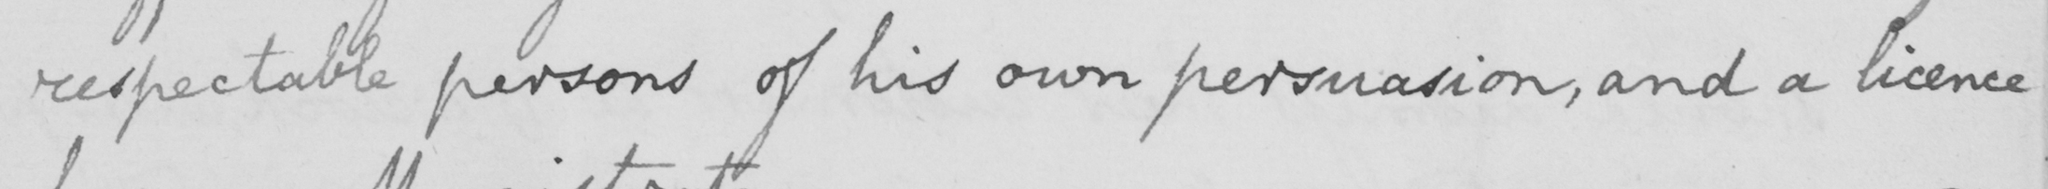What does this handwritten line say? respectable persons of his own persuasion , and a licence 